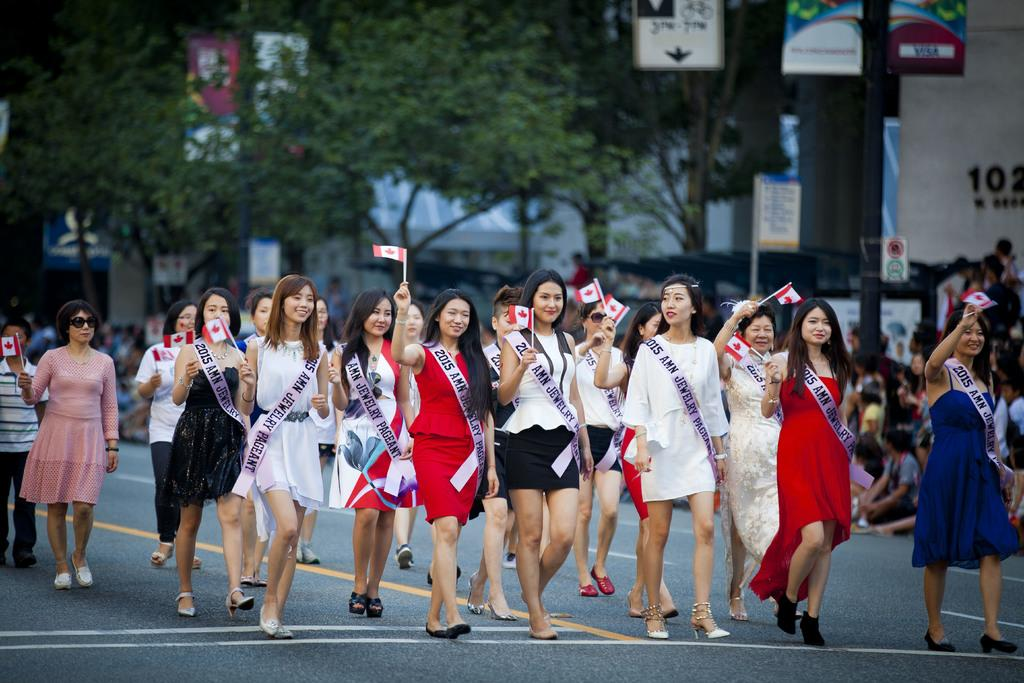How many people are in the image? There are many ladies in the image. What are the ladies doing in the image? The ladies are walking on the road. What are the ladies holding in the image? The ladies are holding flags. What are the ladies wearing across their bodies? The ladies are wearing sashes across their bodies. How many hands does the woman in the image have? There is no specific woman mentioned in the image, and the number of hands cannot be determined from the provided facts. 